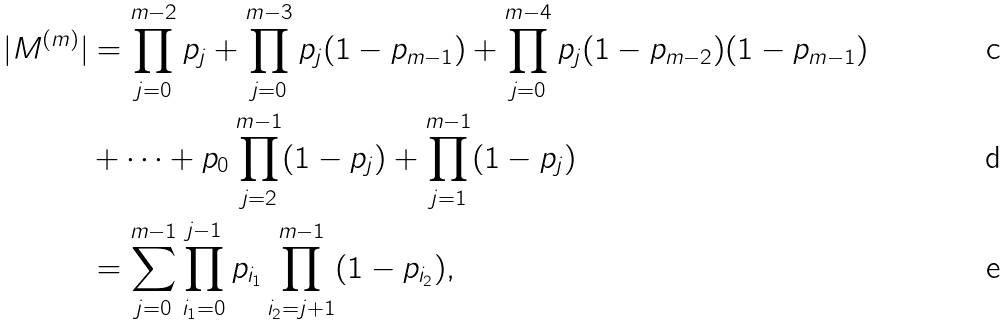Convert formula to latex. <formula><loc_0><loc_0><loc_500><loc_500>| M ^ { ( m ) } | & = \prod _ { j = 0 } ^ { m - 2 } p _ { j } + \prod _ { j = 0 } ^ { m - 3 } p _ { j } ( 1 - p _ { m - 1 } ) + \prod _ { j = 0 } ^ { m - 4 } p _ { j } ( 1 - p _ { m - 2 } ) ( 1 - p _ { m - 1 } ) \\ & + \cdots + p _ { 0 } \prod _ { j = 2 } ^ { m - 1 } ( 1 - p _ { j } ) + \prod _ { j = 1 } ^ { m - 1 } ( 1 - p _ { j } ) \\ & = \sum _ { j = 0 } ^ { m - 1 } \prod _ { i _ { 1 } = 0 } ^ { j - 1 } p _ { i _ { 1 } } \prod _ { i _ { 2 } = j + 1 } ^ { m - 1 } ( 1 - p _ { i _ { 2 } } ) ,</formula> 